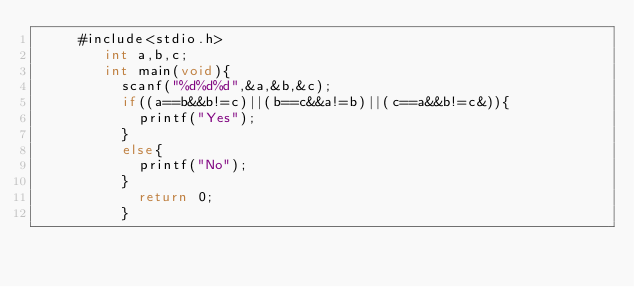Convert code to text. <code><loc_0><loc_0><loc_500><loc_500><_C_>     #include<stdio.h>
        int a,b,c;
        int main(void){
          scanf("%d%d%d",&a,&b,&c);
          if((a==b&&b!=c)||(b==c&&a!=b)||(c==a&&b!=c&)){
            printf("Yes");
          }
          else{
            printf("No");
          }
            return 0;
          }</code> 